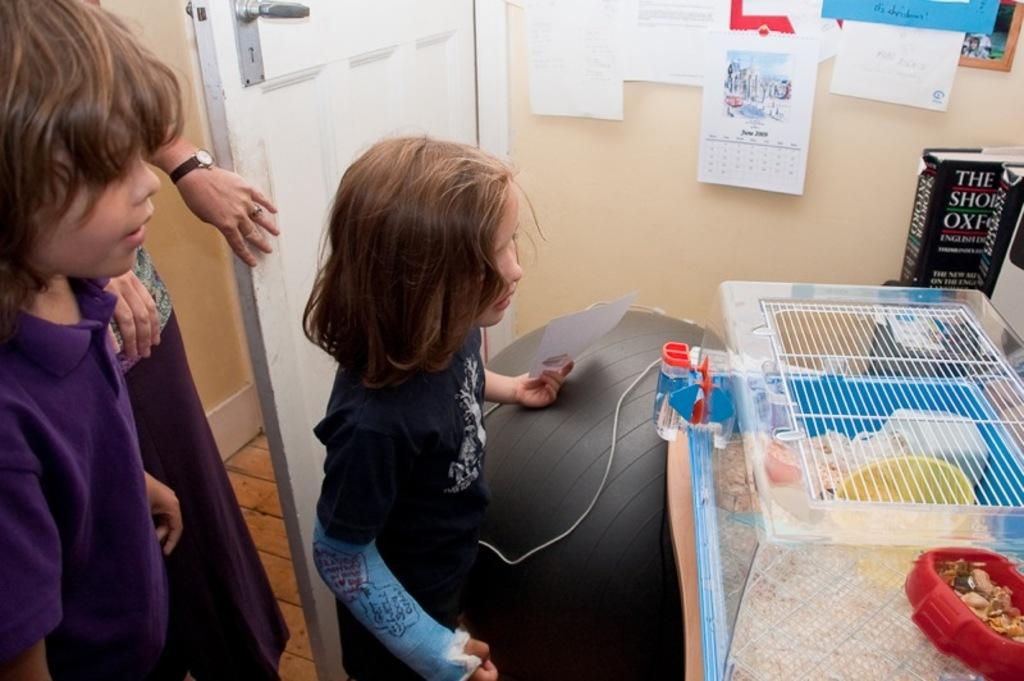<image>
Create a compact narrative representing the image presented. Kids look a ta hamster cage that sits next to a book that starts with The Oxford. 